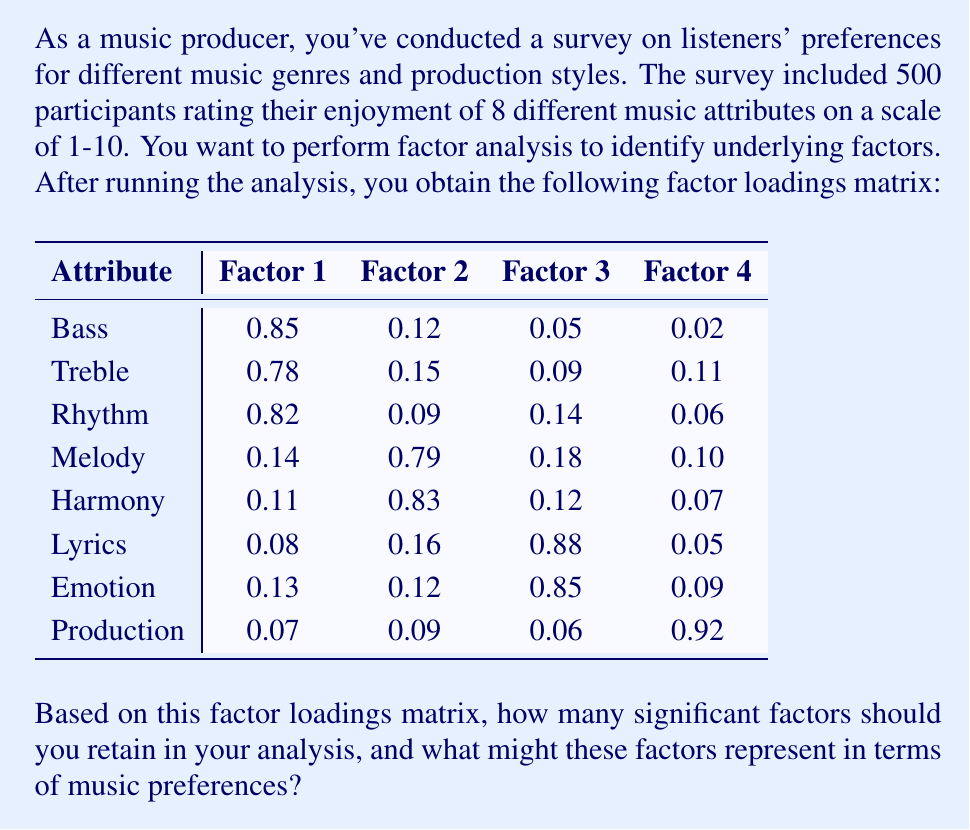What is the answer to this math problem? To determine the number of significant factors and interpret them, we'll follow these steps:

1. Examine the factor loadings:
   - Look for loadings greater than 0.5, which are generally considered significant.
   - Identify which attributes load heavily on each factor.

2. Count significant factors:
   - A factor is considered significant if it has at least one attribute with a high loading (>0.5).

3. Interpret the factors:
   - Group attributes that load heavily on the same factor.
   - Consider what these attributes have in common to name the factor.

Analysis:
Factor 1:
- High loadings: Bass (0.85), Treble (0.78), Rhythm (0.82)
- Interpretation: This factor represents "Sound and Rhythm"

Factor 2:
- High loadings: Melody (0.79), Harmony (0.83)
- Interpretation: This factor represents "Musical Structure"

Factor 3:
- High loadings: Lyrics (0.88), Emotion (0.85)
- Interpretation: This factor represents "Lyrical and Emotional Content"

Factor 4:
- High loading: Production (0.92)
- Interpretation: This factor represents "Production Quality"

All four factors have at least one attribute with a loading greater than 0.5, so we should retain all four factors.

These factors represent different aspects of music preferences:
1. Sound and Rhythm
2. Musical Structure
3. Lyrical and Emotional Content
4. Production Quality
Answer: 4 factors: Sound and Rhythm, Musical Structure, Lyrical and Emotional Content, Production Quality 